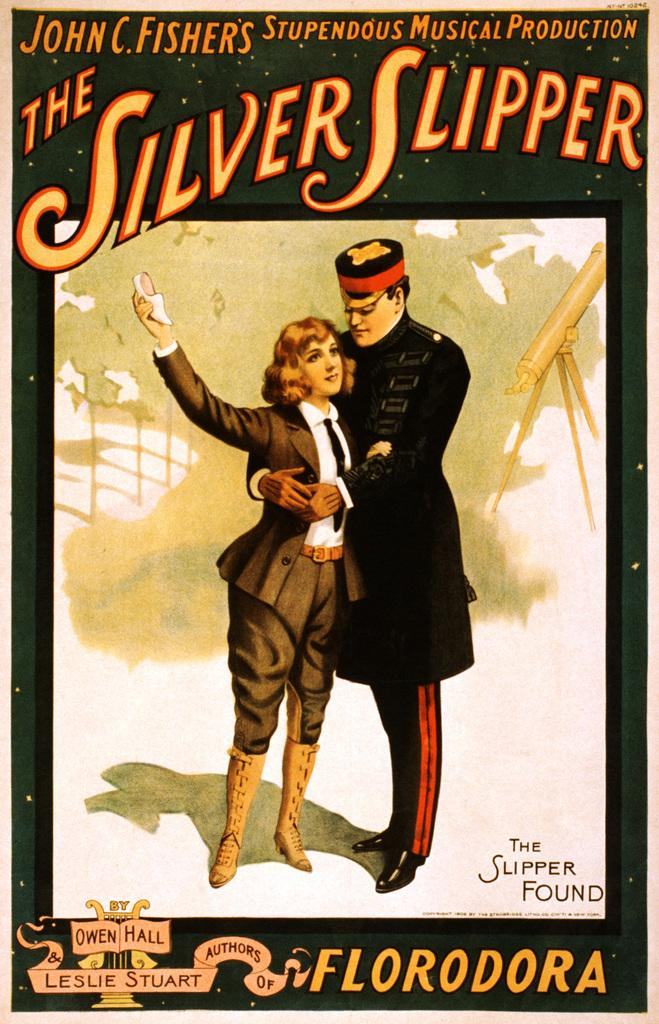<image>
Present a compact description of the photo's key features. John C Fisher's The Silver Slipper movie poster. 